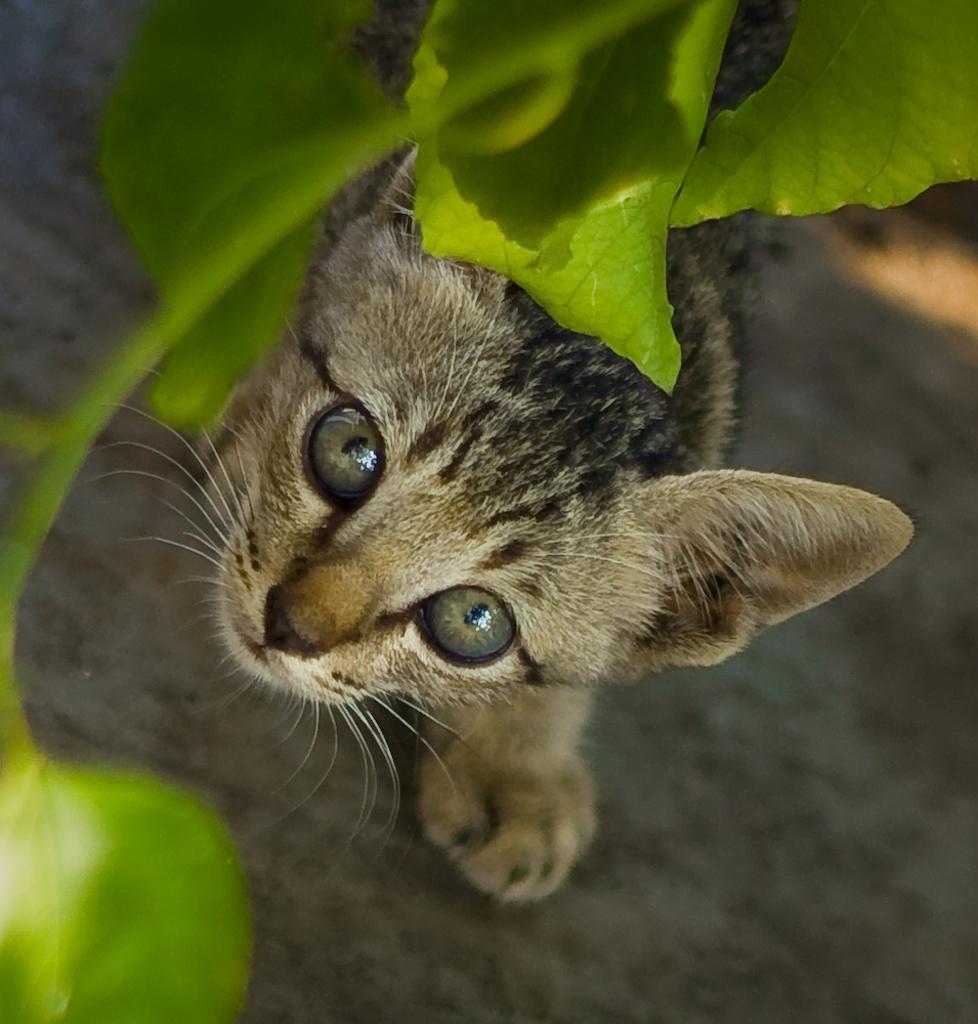Can you describe this image briefly? In this image there is a cat which is standing on the road and seeing the leaves which are in front of the cat. 